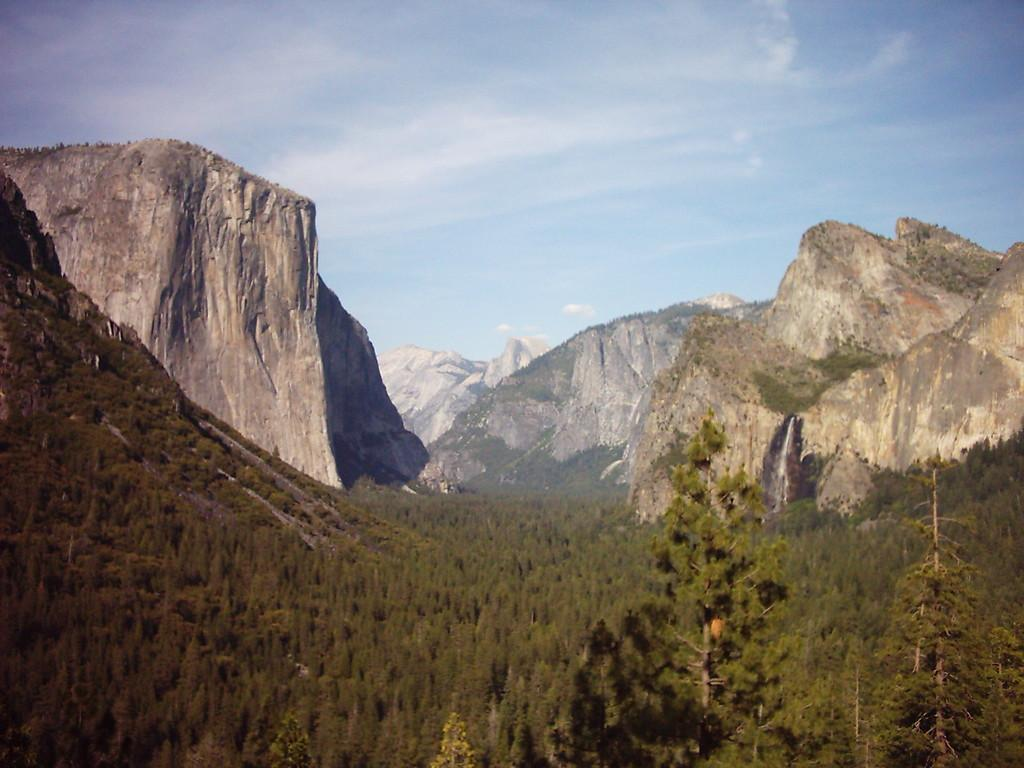What type of vegetation can be seen in the image? There are trees in the image. What geographical features are present in the image? There are hills in the image. What is visible in the sky in the image? The sky is visible in the image. What can be observed in the sky in the image? Clouds are present in the sky. How does the disgust feel in the image? There is no mention of disgust in the image, as it only contains trees, hills, sky, and clouds. What is the afterthought of the ear in the image? There is no ear present in the image, so it is not possible to discuss its afterthought. 